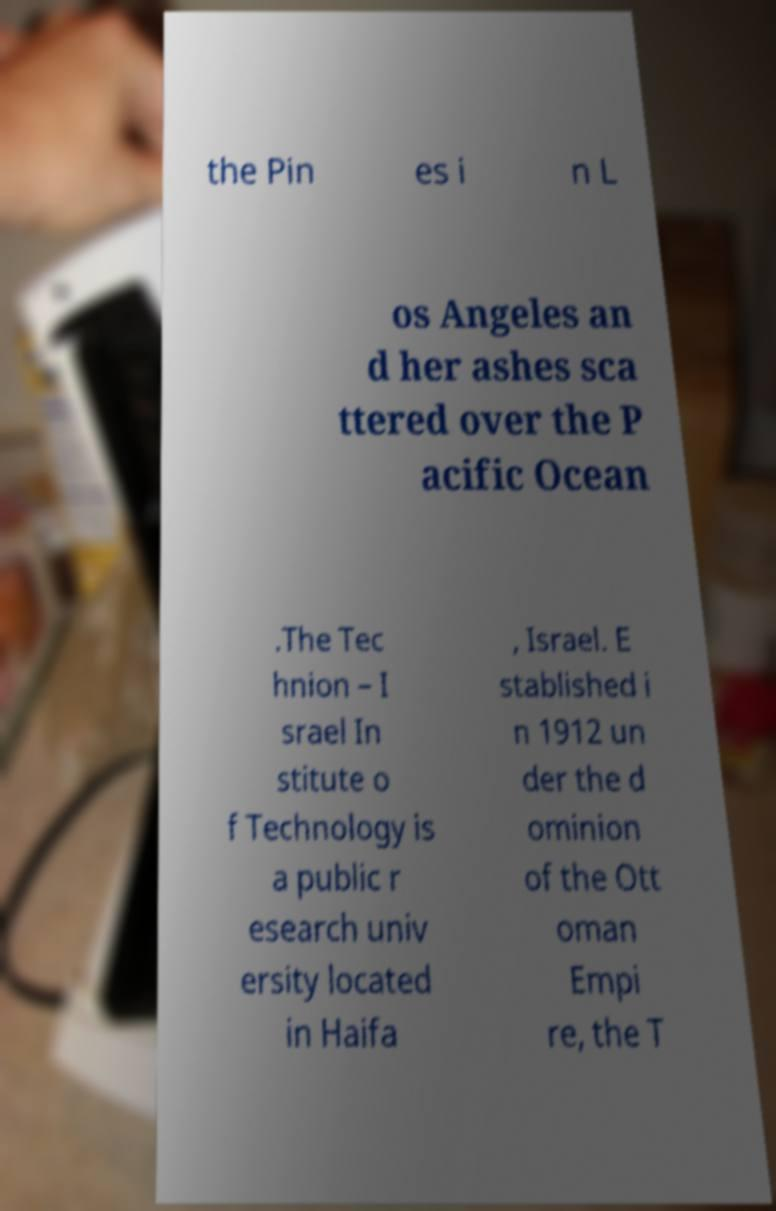Could you assist in decoding the text presented in this image and type it out clearly? the Pin es i n L os Angeles an d her ashes sca ttered over the P acific Ocean .The Tec hnion – I srael In stitute o f Technology is a public r esearch univ ersity located in Haifa , Israel. E stablished i n 1912 un der the d ominion of the Ott oman Empi re, the T 